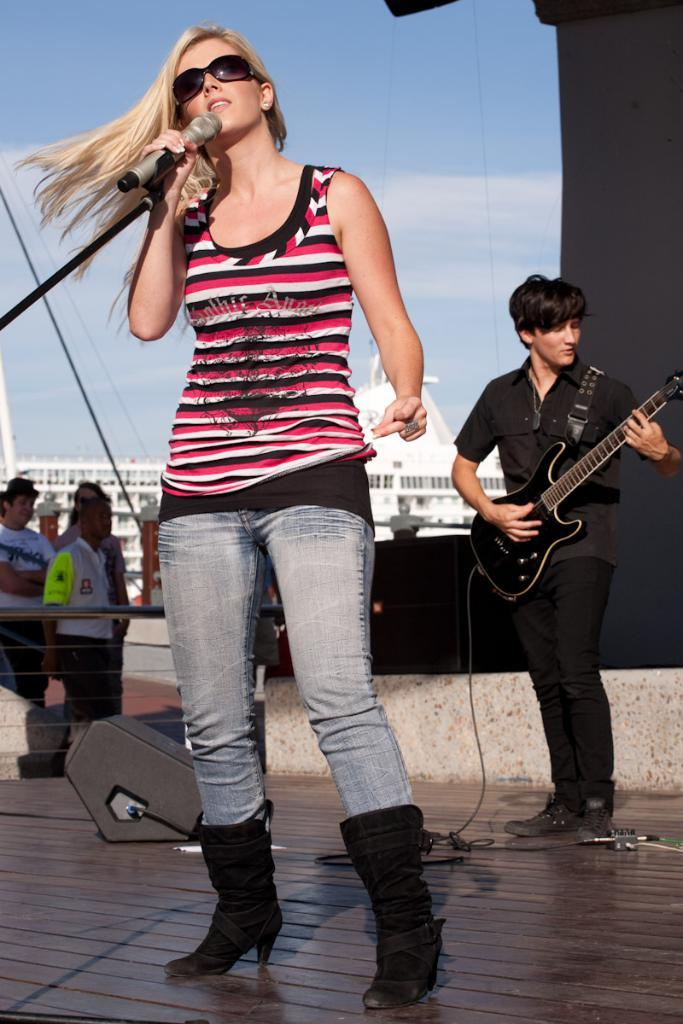What is the woman in the image doing? The woman is standing and singing, and she is holding a microphone. What is the man in the image doing? The man is standing and playing the guitar. What can be seen in the background of the image? There is a building in the background of the image. What is the weather like in the image? It is a sunny day. What type of skin condition can be seen on the woman's wrist in the image? There is no mention of any skin condition or issue on the woman's wrist in the image. How many balls are visible in the image? There are no balls present in the image. 